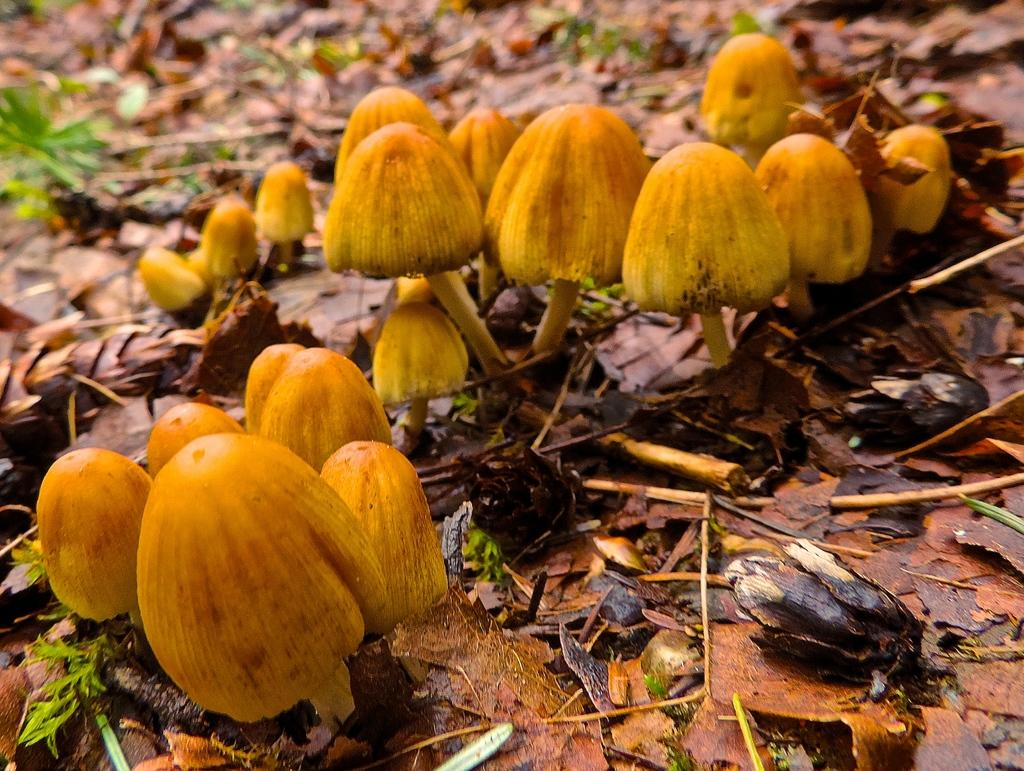What type of fungi can be seen in the image? There are mushrooms in the image. What type of vegetation is present in the image? There are leaves and plants in the image. What type of hammer can be seen in the image? There is no hammer present in the image. How many eggs are visible in the image? There are no eggs present in the image. 